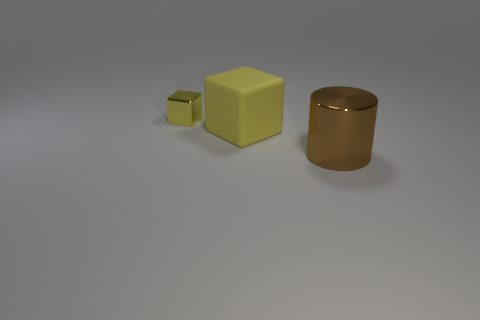What color is the large object that is on the left side of the large thing that is on the right side of the large yellow cube?
Offer a terse response. Yellow. How many other objects are there of the same color as the metallic cylinder?
Offer a very short reply. 0. How many things are either objects or cubes behind the rubber thing?
Provide a short and direct response. 3. What color is the block in front of the small yellow metallic cube?
Give a very brief answer. Yellow. The big matte object is what shape?
Offer a very short reply. Cube. What material is the object that is right of the yellow block on the right side of the tiny object?
Offer a terse response. Metal. How many other objects are there of the same material as the tiny yellow block?
Make the answer very short. 1. There is a thing that is the same size as the cylinder; what is its material?
Provide a short and direct response. Rubber. Is the number of tiny metallic things that are left of the tiny yellow metallic block greater than the number of big brown cylinders in front of the cylinder?
Give a very brief answer. No. Is there a tiny shiny object of the same shape as the big matte thing?
Ensure brevity in your answer.  Yes. 